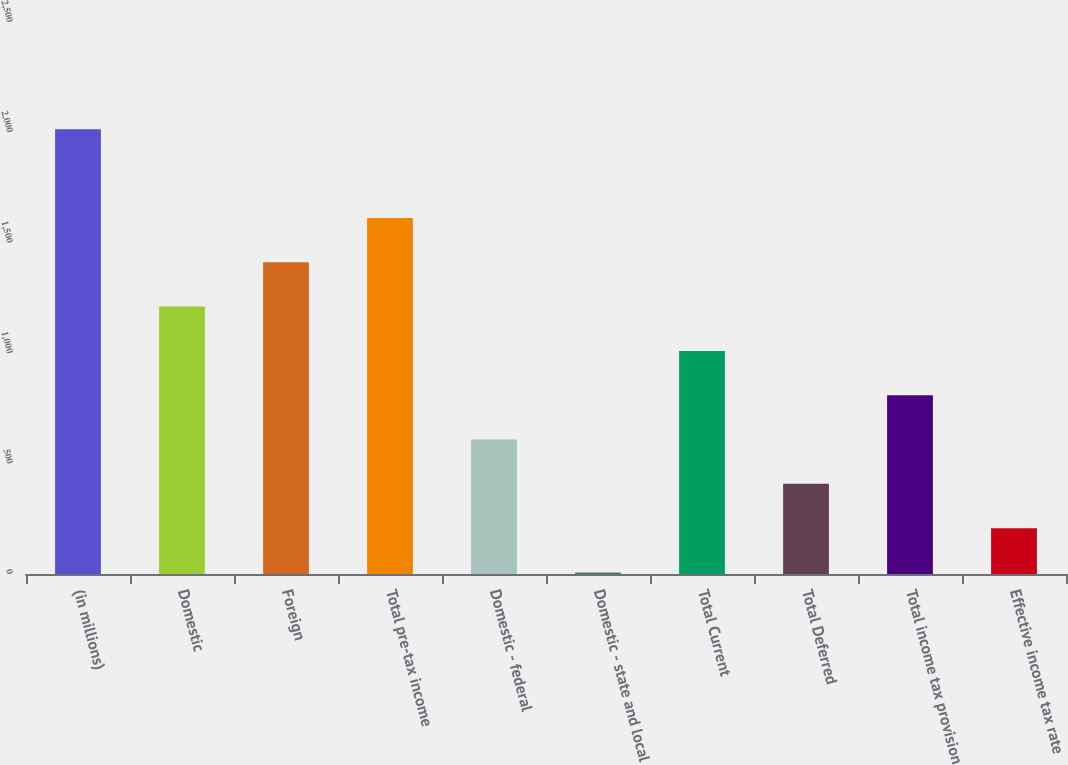<chart> <loc_0><loc_0><loc_500><loc_500><bar_chart><fcel>(in millions)<fcel>Domestic<fcel>Foreign<fcel>Total pre-tax income<fcel>Domestic - federal<fcel>Domestic - state and local<fcel>Total Current<fcel>Total Deferred<fcel>Total income tax provision<fcel>Effective income tax rate<nl><fcel>2014<fcel>1211.2<fcel>1411.9<fcel>1612.6<fcel>609.1<fcel>7<fcel>1010.5<fcel>408.4<fcel>809.8<fcel>207.7<nl></chart> 